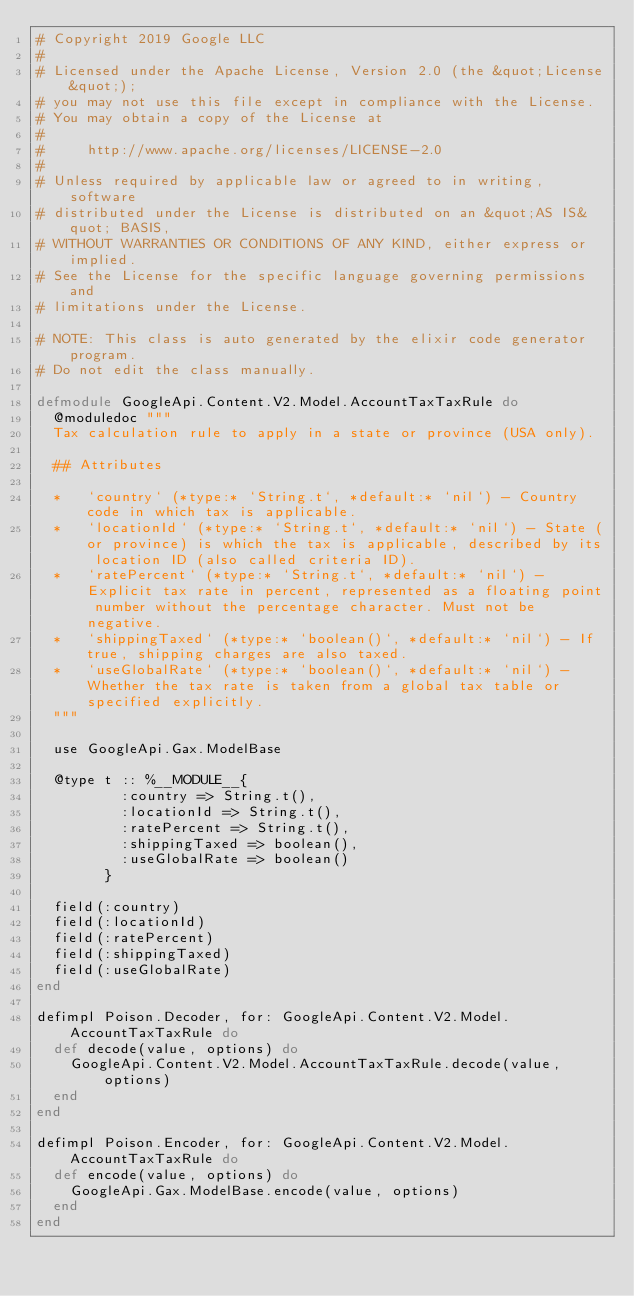Convert code to text. <code><loc_0><loc_0><loc_500><loc_500><_Elixir_># Copyright 2019 Google LLC
#
# Licensed under the Apache License, Version 2.0 (the &quot;License&quot;);
# you may not use this file except in compliance with the License.
# You may obtain a copy of the License at
#
#     http://www.apache.org/licenses/LICENSE-2.0
#
# Unless required by applicable law or agreed to in writing, software
# distributed under the License is distributed on an &quot;AS IS&quot; BASIS,
# WITHOUT WARRANTIES OR CONDITIONS OF ANY KIND, either express or implied.
# See the License for the specific language governing permissions and
# limitations under the License.

# NOTE: This class is auto generated by the elixir code generator program.
# Do not edit the class manually.

defmodule GoogleApi.Content.V2.Model.AccountTaxTaxRule do
  @moduledoc """
  Tax calculation rule to apply in a state or province (USA only).

  ## Attributes

  *   `country` (*type:* `String.t`, *default:* `nil`) - Country code in which tax is applicable.
  *   `locationId` (*type:* `String.t`, *default:* `nil`) - State (or province) is which the tax is applicable, described by its location ID (also called criteria ID).
  *   `ratePercent` (*type:* `String.t`, *default:* `nil`) - Explicit tax rate in percent, represented as a floating point number without the percentage character. Must not be negative.
  *   `shippingTaxed` (*type:* `boolean()`, *default:* `nil`) - If true, shipping charges are also taxed.
  *   `useGlobalRate` (*type:* `boolean()`, *default:* `nil`) - Whether the tax rate is taken from a global tax table or specified explicitly.
  """

  use GoogleApi.Gax.ModelBase

  @type t :: %__MODULE__{
          :country => String.t(),
          :locationId => String.t(),
          :ratePercent => String.t(),
          :shippingTaxed => boolean(),
          :useGlobalRate => boolean()
        }

  field(:country)
  field(:locationId)
  field(:ratePercent)
  field(:shippingTaxed)
  field(:useGlobalRate)
end

defimpl Poison.Decoder, for: GoogleApi.Content.V2.Model.AccountTaxTaxRule do
  def decode(value, options) do
    GoogleApi.Content.V2.Model.AccountTaxTaxRule.decode(value, options)
  end
end

defimpl Poison.Encoder, for: GoogleApi.Content.V2.Model.AccountTaxTaxRule do
  def encode(value, options) do
    GoogleApi.Gax.ModelBase.encode(value, options)
  end
end
</code> 